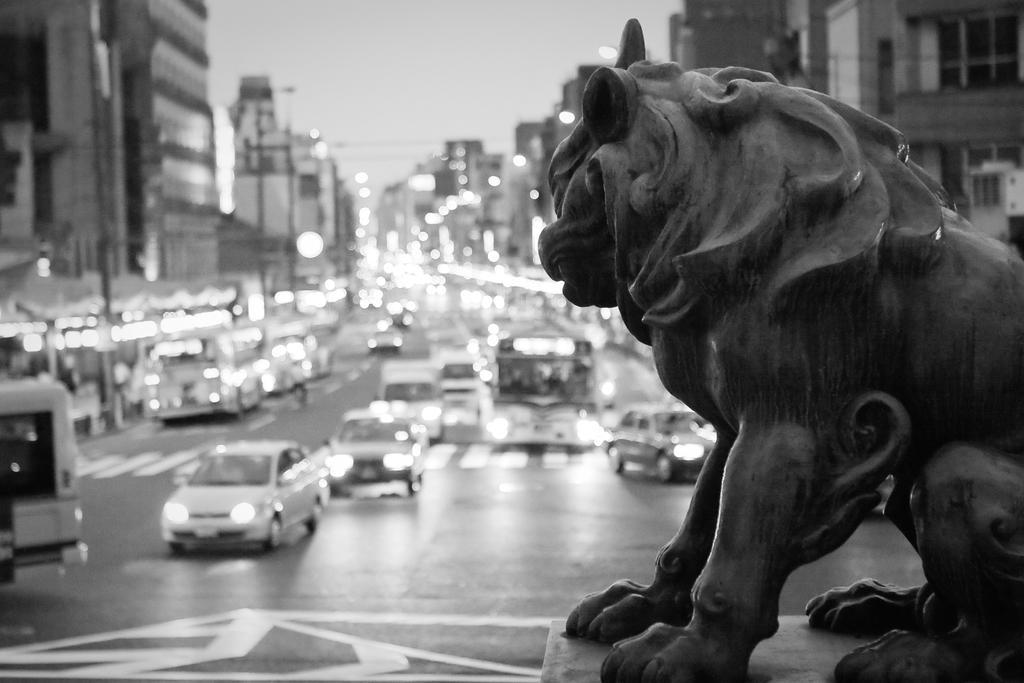Please provide a concise description of this image. In this image we can see a statue few vehicles on the road, there are few buildings and the sky in the background. 